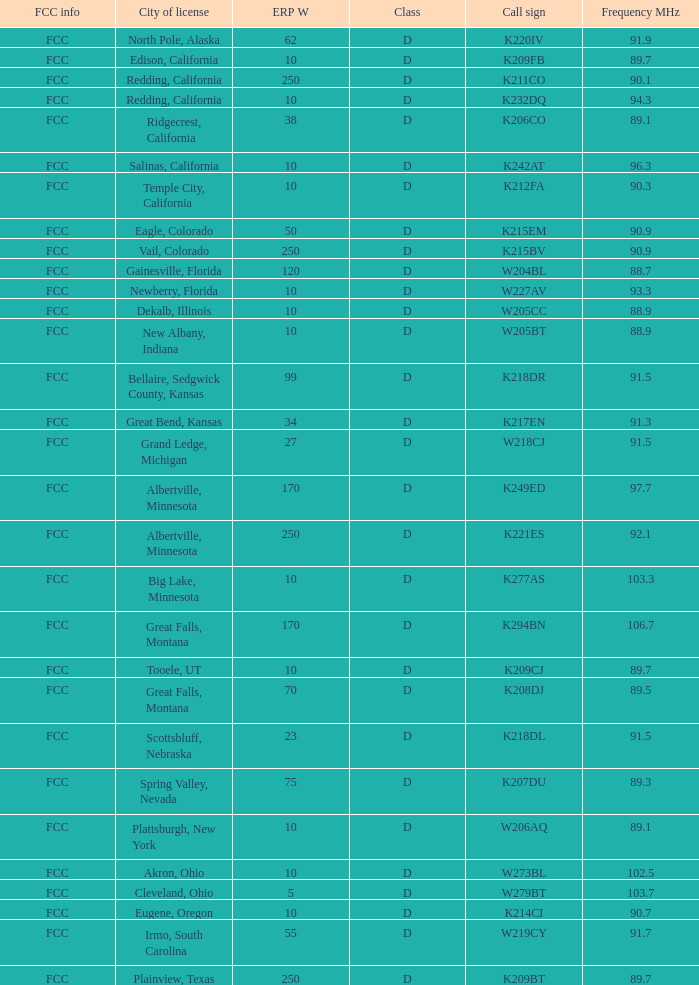What information does the fcc provide about the translator licensed in the city of irmo, south carolina? FCC. 